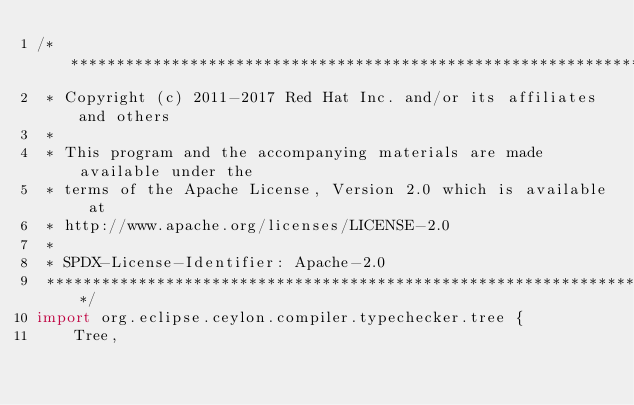<code> <loc_0><loc_0><loc_500><loc_500><_Ceylon_>/********************************************************************************
 * Copyright (c) 2011-2017 Red Hat Inc. and/or its affiliates and others
 *
 * This program and the accompanying materials are made available under the 
 * terms of the Apache License, Version 2.0 which is available at
 * http://www.apache.org/licenses/LICENSE-2.0
 *
 * SPDX-License-Identifier: Apache-2.0 
 ********************************************************************************/
import org.eclipse.ceylon.compiler.typechecker.tree {
    Tree,</code> 